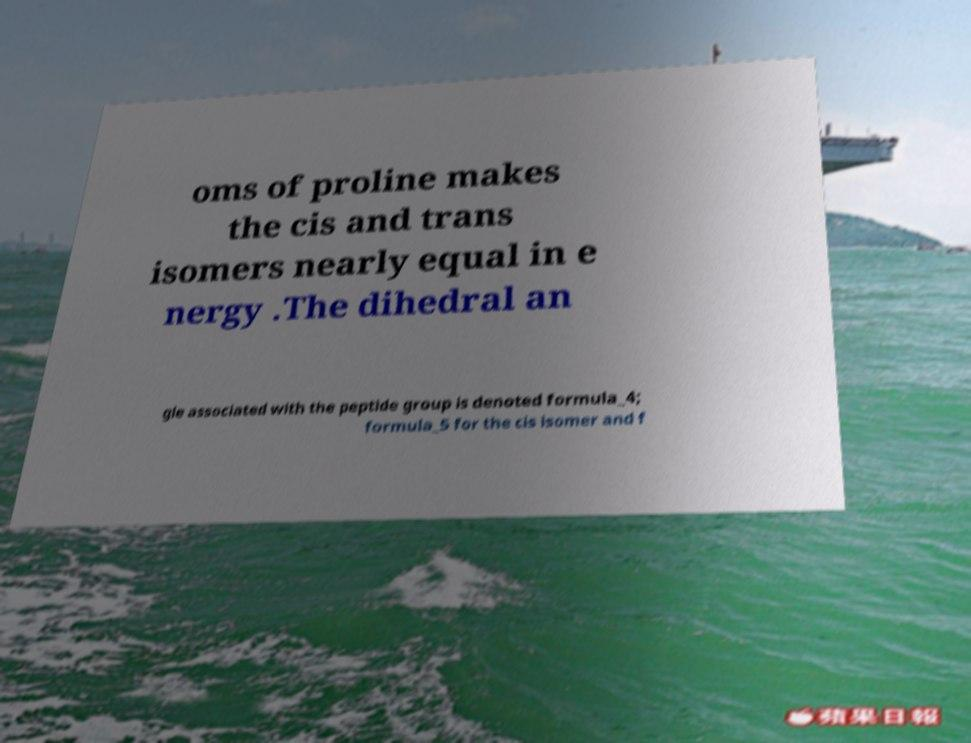Could you extract and type out the text from this image? oms of proline makes the cis and trans isomers nearly equal in e nergy .The dihedral an gle associated with the peptide group is denoted formula_4; formula_5 for the cis isomer and f 